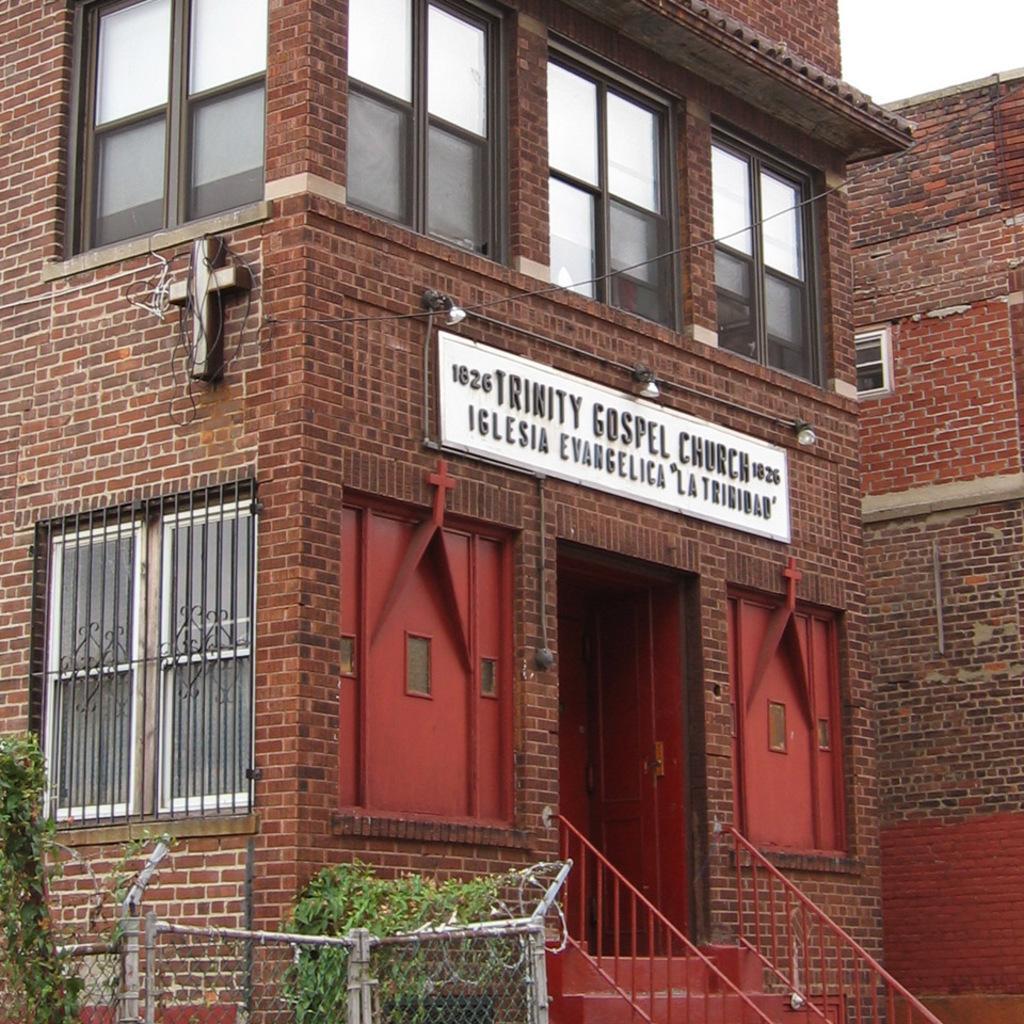Could you give a brief overview of what you see in this image? In this picture we can see buildings, here we can see a name board and plants. 